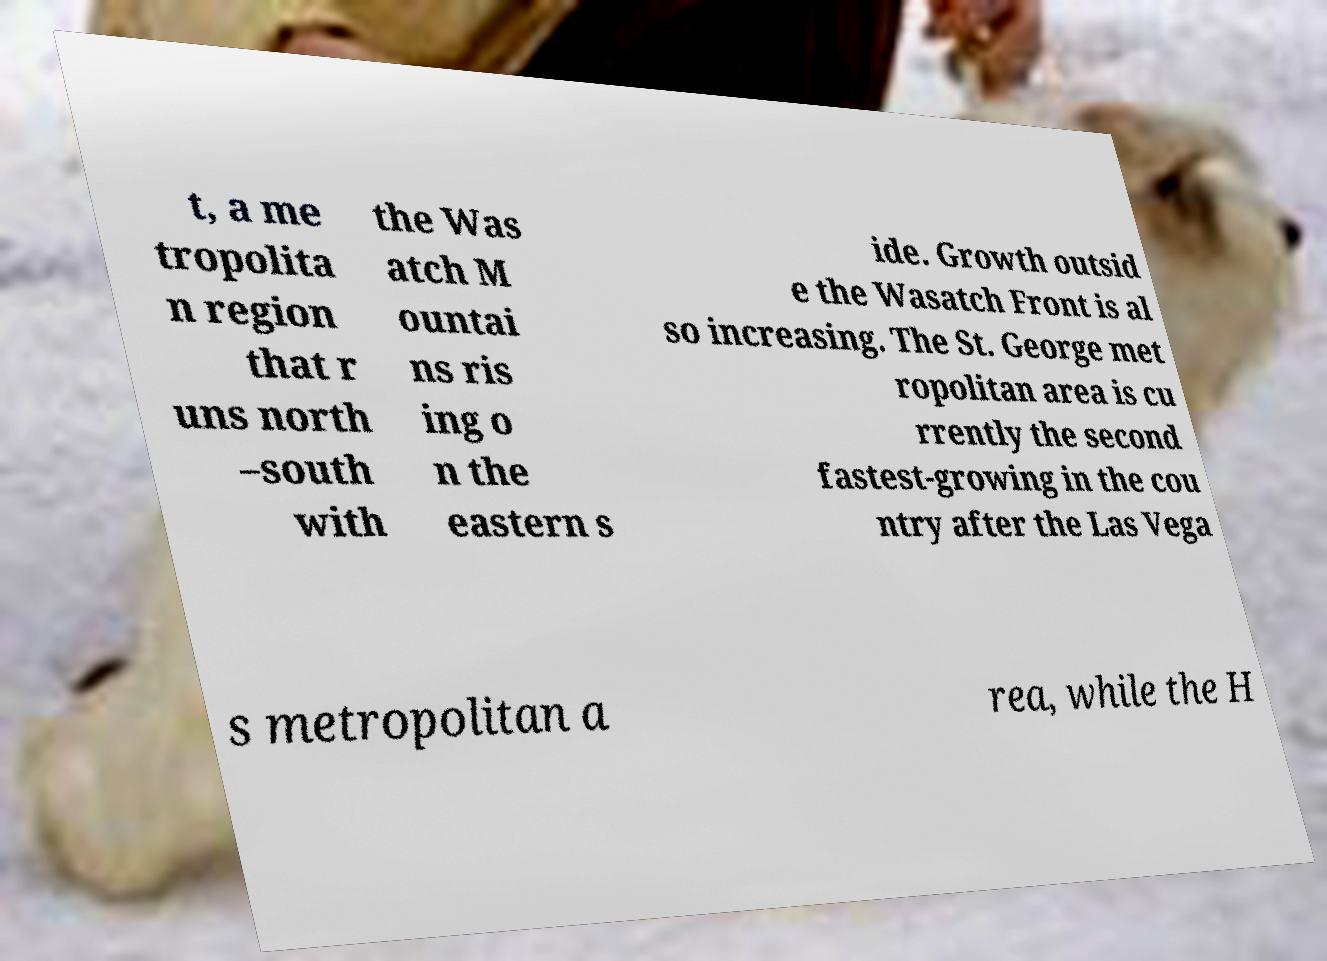What messages or text are displayed in this image? I need them in a readable, typed format. t, a me tropolita n region that r uns north –south with the Was atch M ountai ns ris ing o n the eastern s ide. Growth outsid e the Wasatch Front is al so increasing. The St. George met ropolitan area is cu rrently the second fastest-growing in the cou ntry after the Las Vega s metropolitan a rea, while the H 